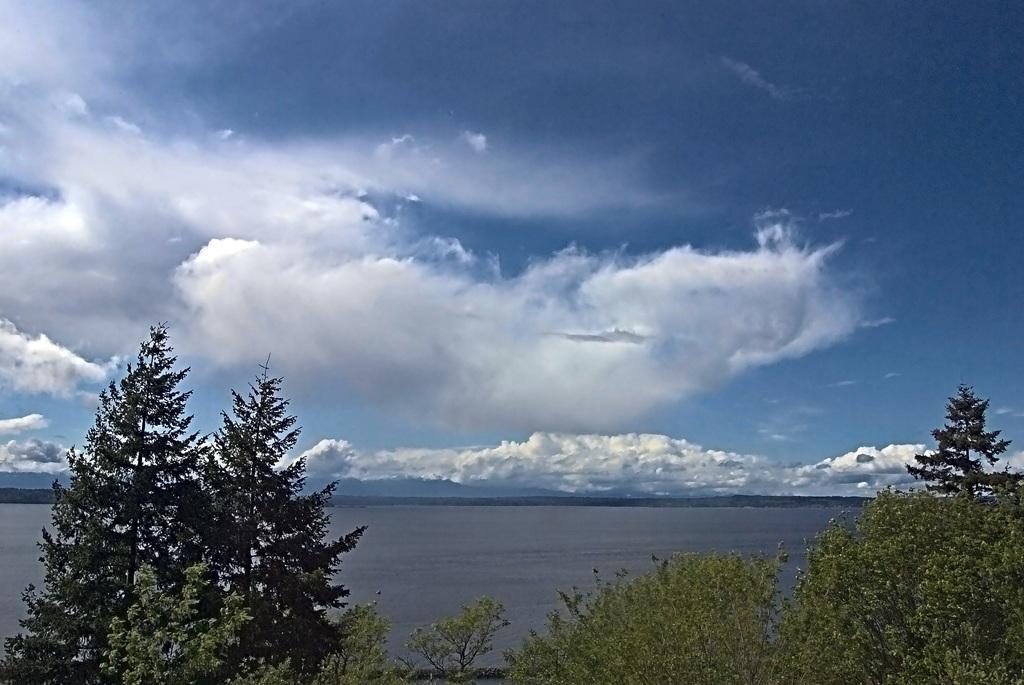What type of natural environment is depicted in the image? There is a sea in the image. What type of vegetation can be seen in the image? There are trees in the image. What is visible in the sky in the image? The sky is visible in the image. How many books can be seen on the zebra in the image? There are no books or zebras present in the image. 